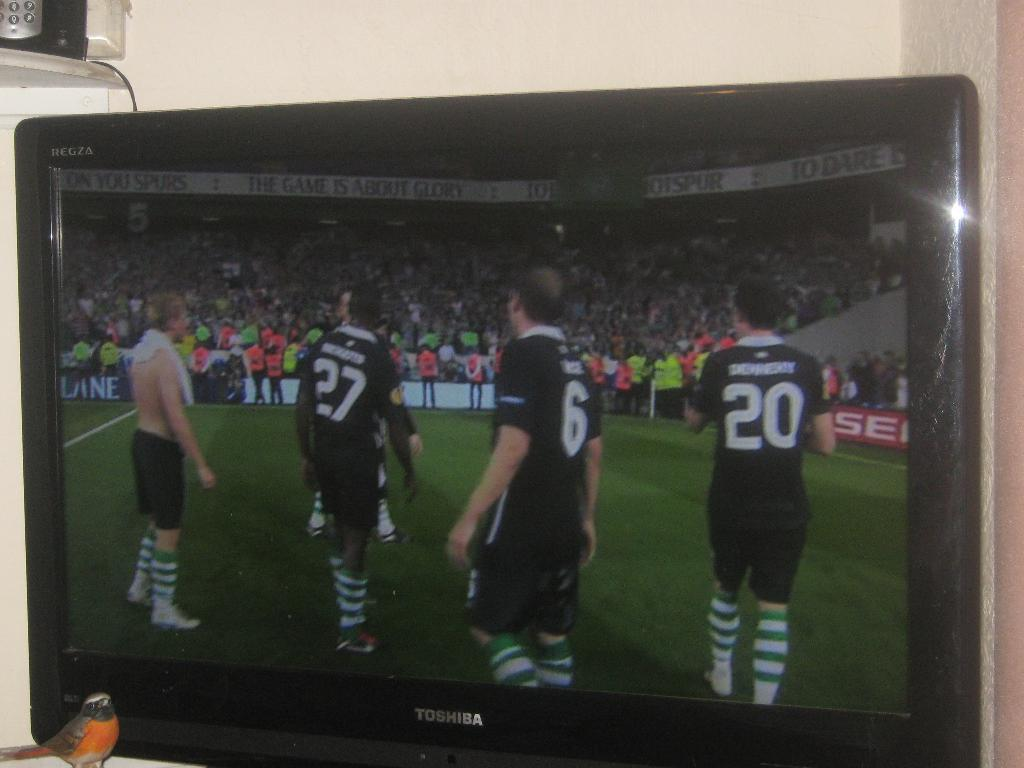<image>
Render a clear and concise summary of the photo. The screen of a toshiba branded television showing a soccer game with a bird standing near the television. 